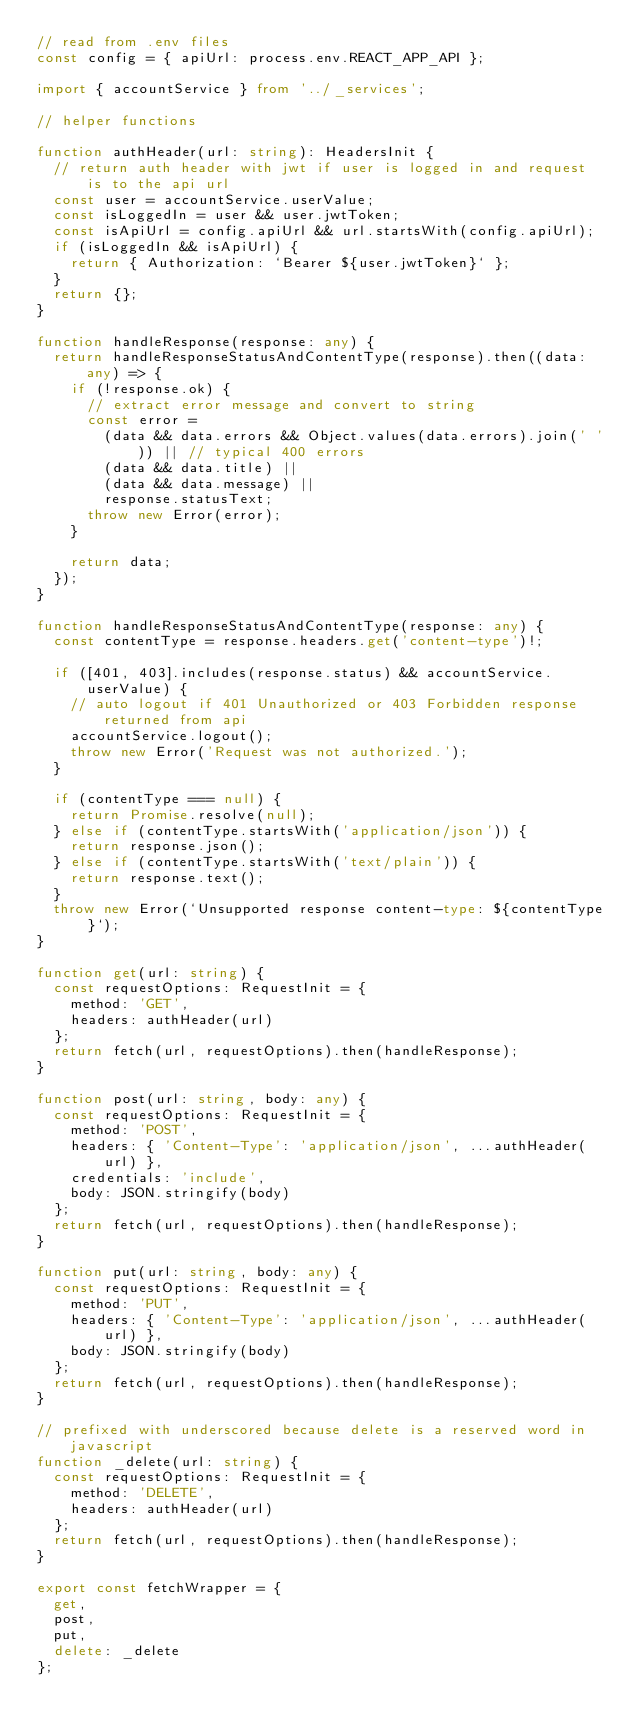Convert code to text. <code><loc_0><loc_0><loc_500><loc_500><_TypeScript_>// read from .env files
const config = { apiUrl: process.env.REACT_APP_API };

import { accountService } from '../_services';

// helper functions

function authHeader(url: string): HeadersInit {
  // return auth header with jwt if user is logged in and request is to the api url
  const user = accountService.userValue;
  const isLoggedIn = user && user.jwtToken;
  const isApiUrl = config.apiUrl && url.startsWith(config.apiUrl);
  if (isLoggedIn && isApiUrl) {
    return { Authorization: `Bearer ${user.jwtToken}` };
  }
  return {};
}

function handleResponse(response: any) {
  return handleResponseStatusAndContentType(response).then((data: any) => {
    if (!response.ok) {
      // extract error message and convert to string
      const error =
        (data && data.errors && Object.values(data.errors).join(' ')) || // typical 400 errors
        (data && data.title) ||
        (data && data.message) ||
        response.statusText;
      throw new Error(error);
    }

    return data;
  });
}

function handleResponseStatusAndContentType(response: any) {
  const contentType = response.headers.get('content-type')!;

  if ([401, 403].includes(response.status) && accountService.userValue) {
    // auto logout if 401 Unauthorized or 403 Forbidden response returned from api
    accountService.logout();
    throw new Error('Request was not authorized.');
  }

  if (contentType === null) {
    return Promise.resolve(null);
  } else if (contentType.startsWith('application/json')) {
    return response.json();
  } else if (contentType.startsWith('text/plain')) {
    return response.text();
  }
  throw new Error(`Unsupported response content-type: ${contentType}`);
}

function get(url: string) {
  const requestOptions: RequestInit = {
    method: 'GET',
    headers: authHeader(url)
  };
  return fetch(url, requestOptions).then(handleResponse);
}

function post(url: string, body: any) {
  const requestOptions: RequestInit = {
    method: 'POST',
    headers: { 'Content-Type': 'application/json', ...authHeader(url) },
    credentials: 'include',
    body: JSON.stringify(body)
  };
  return fetch(url, requestOptions).then(handleResponse);
}

function put(url: string, body: any) {
  const requestOptions: RequestInit = {
    method: 'PUT',
    headers: { 'Content-Type': 'application/json', ...authHeader(url) },
    body: JSON.stringify(body)
  };
  return fetch(url, requestOptions).then(handleResponse);
}

// prefixed with underscored because delete is a reserved word in javascript
function _delete(url: string) {
  const requestOptions: RequestInit = {
    method: 'DELETE',
    headers: authHeader(url)
  };
  return fetch(url, requestOptions).then(handleResponse);
}

export const fetchWrapper = {
  get,
  post,
  put,
  delete: _delete
};
</code> 